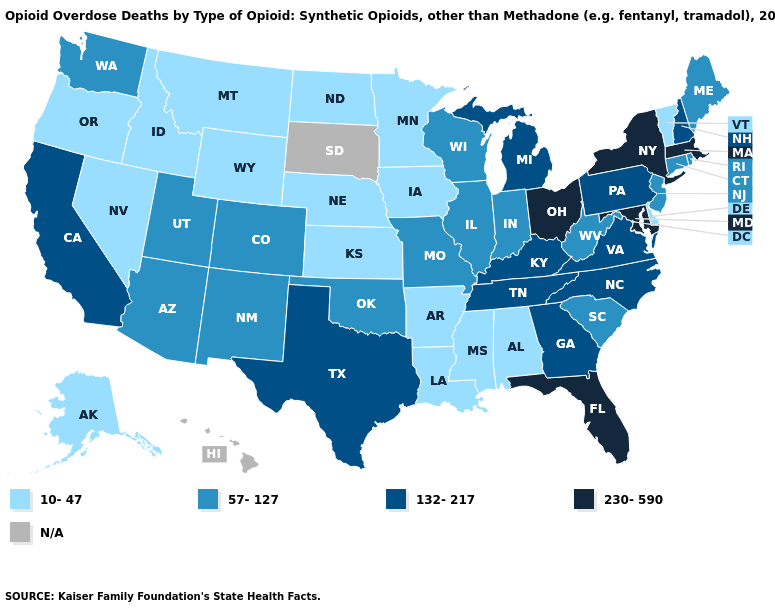Is the legend a continuous bar?
Answer briefly. No. Does Iowa have the lowest value in the USA?
Give a very brief answer. Yes. What is the lowest value in the USA?
Be succinct. 10-47. What is the value of Maryland?
Concise answer only. 230-590. Name the states that have a value in the range 57-127?
Be succinct. Arizona, Colorado, Connecticut, Illinois, Indiana, Maine, Missouri, New Jersey, New Mexico, Oklahoma, Rhode Island, South Carolina, Utah, Washington, West Virginia, Wisconsin. What is the value of New Jersey?
Short answer required. 57-127. What is the value of Oregon?
Short answer required. 10-47. What is the value of Virginia?
Keep it brief. 132-217. Which states have the lowest value in the Northeast?
Be succinct. Vermont. Name the states that have a value in the range 57-127?
Answer briefly. Arizona, Colorado, Connecticut, Illinois, Indiana, Maine, Missouri, New Jersey, New Mexico, Oklahoma, Rhode Island, South Carolina, Utah, Washington, West Virginia, Wisconsin. Is the legend a continuous bar?
Write a very short answer. No. Does Montana have the lowest value in the West?
Short answer required. Yes. Is the legend a continuous bar?
Answer briefly. No. 